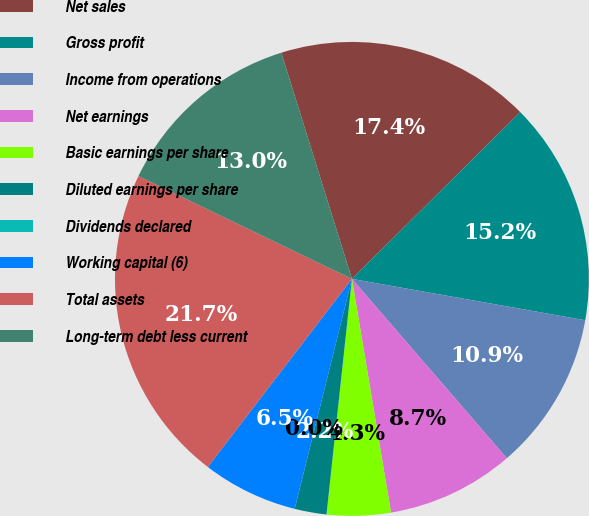Convert chart to OTSL. <chart><loc_0><loc_0><loc_500><loc_500><pie_chart><fcel>Net sales<fcel>Gross profit<fcel>Income from operations<fcel>Net earnings<fcel>Basic earnings per share<fcel>Diluted earnings per share<fcel>Dividends declared<fcel>Working capital (6)<fcel>Total assets<fcel>Long-term debt less current<nl><fcel>17.39%<fcel>15.22%<fcel>10.87%<fcel>8.7%<fcel>4.35%<fcel>2.17%<fcel>0.0%<fcel>6.52%<fcel>21.74%<fcel>13.04%<nl></chart> 